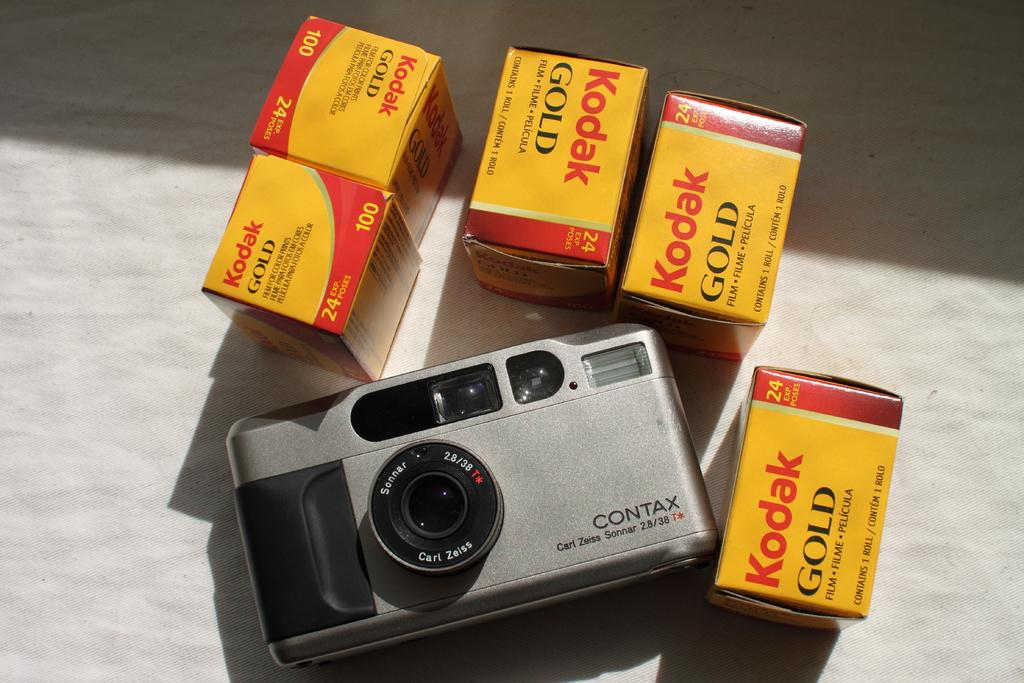What is the main object in the image? There is a camera in the image. What is associated with the camera in the image? There are camera reels in the image. What color is the background of the image? The background of the image is white. How much pain is the camera experiencing in the image? There is no indication of pain in the image, as cameras do not experience pain. 